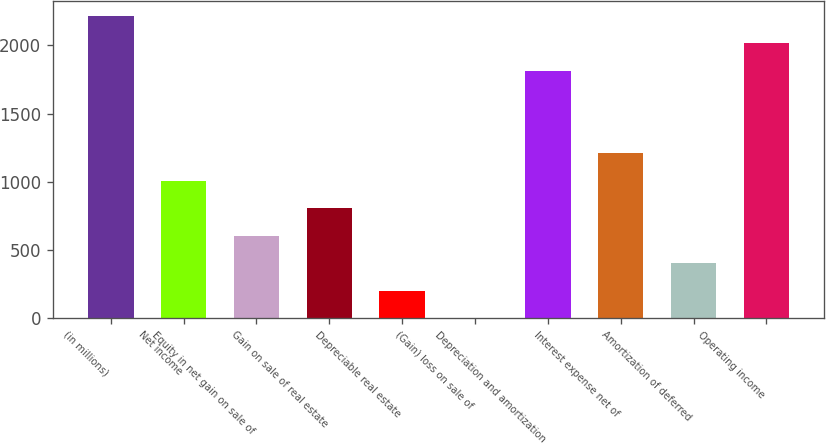<chart> <loc_0><loc_0><loc_500><loc_500><bar_chart><fcel>(in millions)<fcel>Net income<fcel>Equity in net gain on sale of<fcel>Gain on sale of real estate<fcel>Depreciable real estate<fcel>(Gain) loss on sale of<fcel>Depreciation and amortization<fcel>Interest expense net of<fcel>Amortization of deferred<fcel>Operating income<nl><fcel>2217.59<fcel>1008.05<fcel>604.87<fcel>806.46<fcel>201.69<fcel>0.1<fcel>1814.41<fcel>1209.64<fcel>403.28<fcel>2016<nl></chart> 